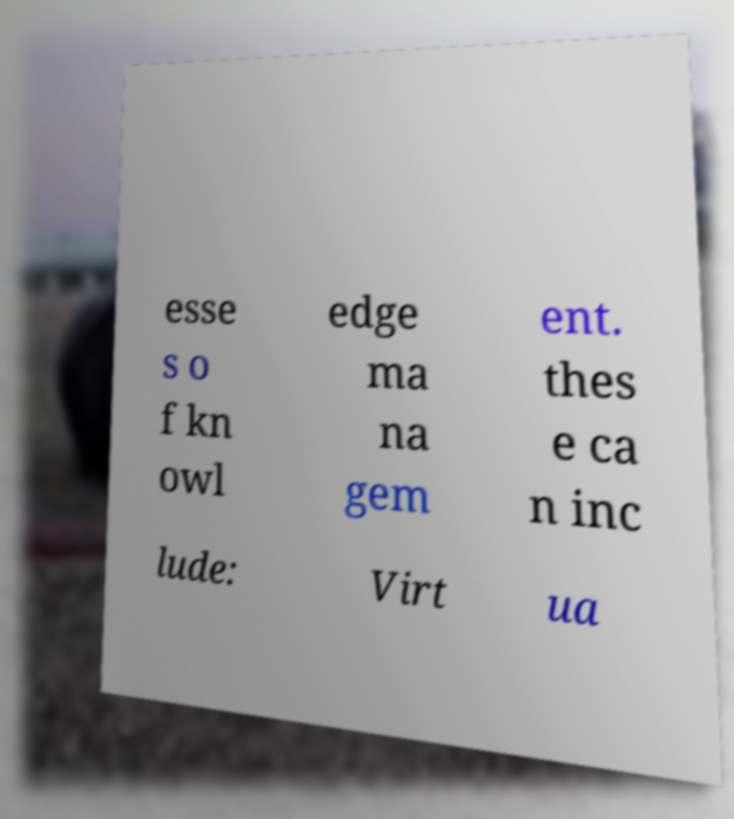I need the written content from this picture converted into text. Can you do that? esse s o f kn owl edge ma na gem ent. thes e ca n inc lude: Virt ua 